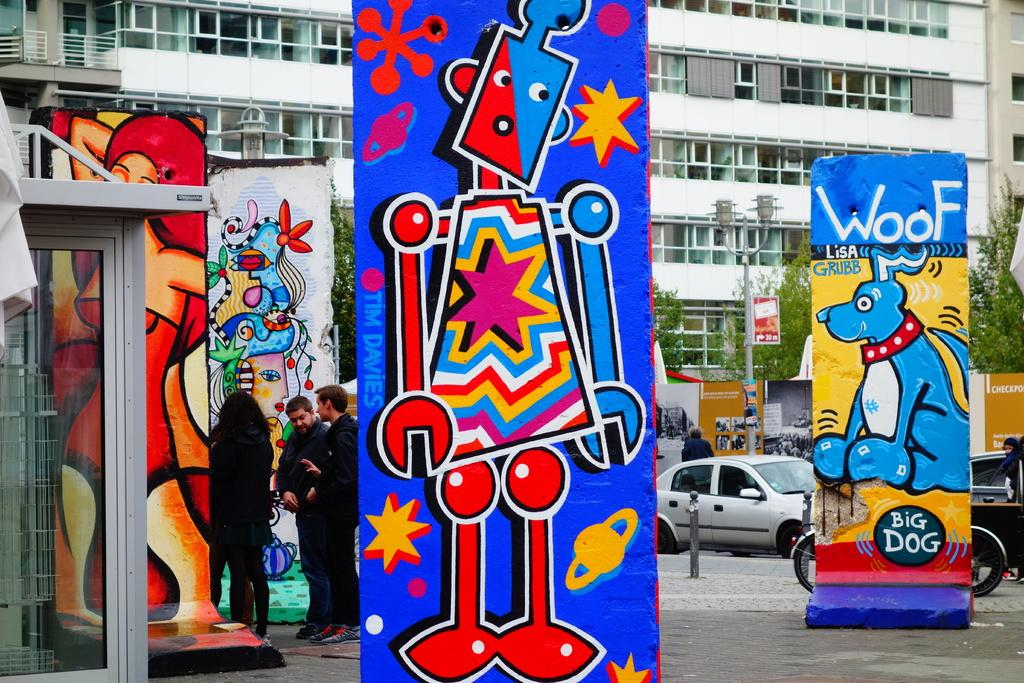<image>
Provide a brief description of the given image. A large piece of art has the name Lisa Grubb  on it. 